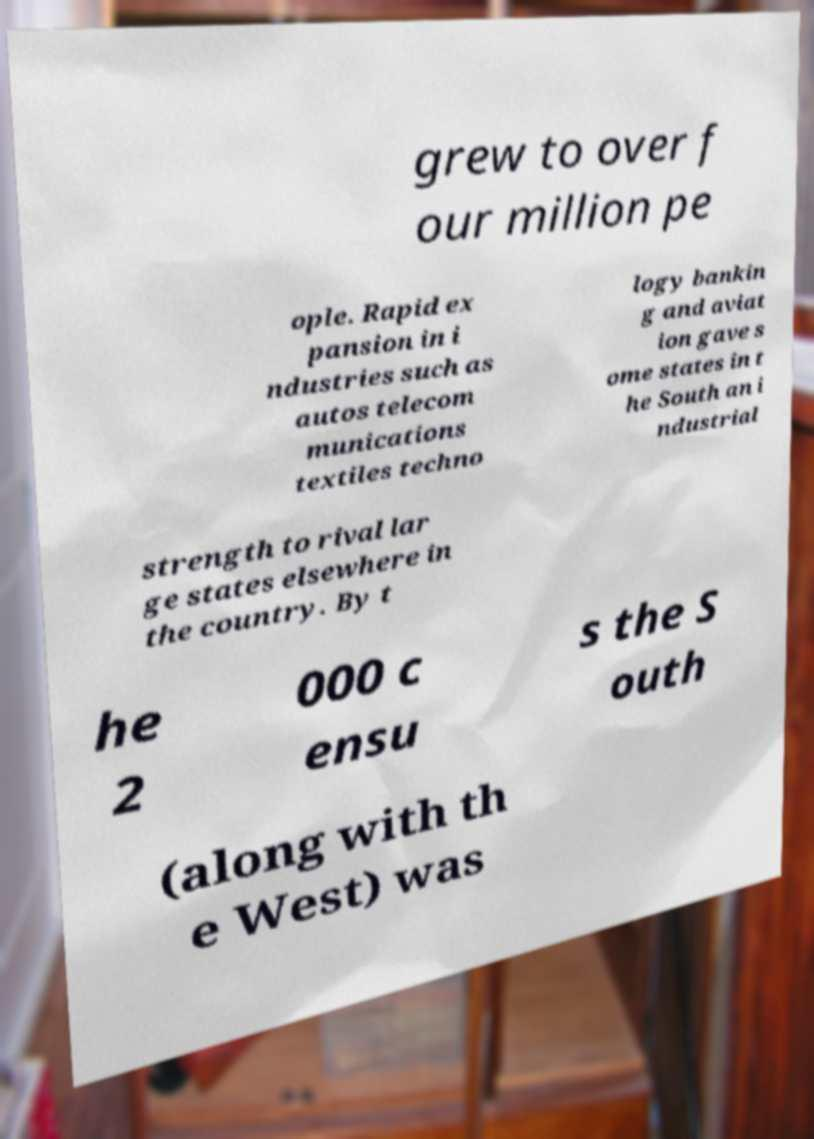What messages or text are displayed in this image? I need them in a readable, typed format. grew to over f our million pe ople. Rapid ex pansion in i ndustries such as autos telecom munications textiles techno logy bankin g and aviat ion gave s ome states in t he South an i ndustrial strength to rival lar ge states elsewhere in the country. By t he 2 000 c ensu s the S outh (along with th e West) was 